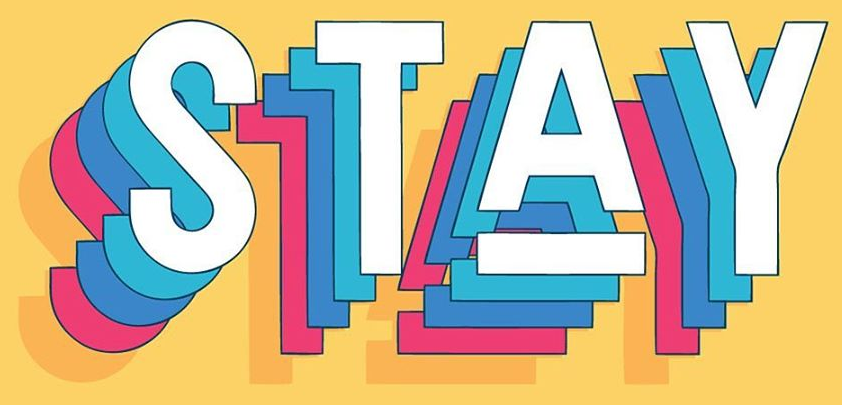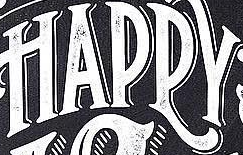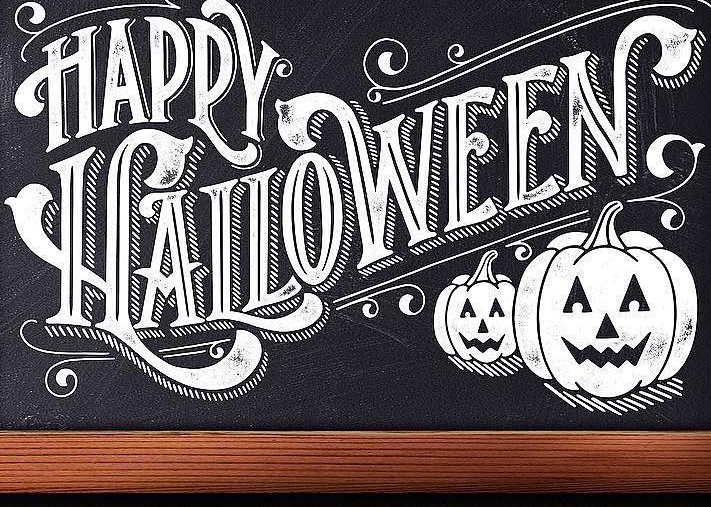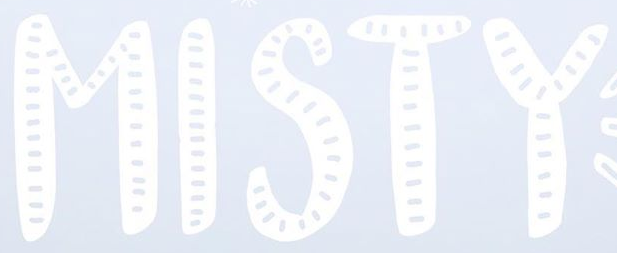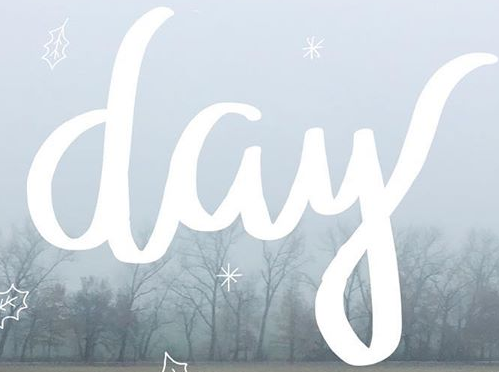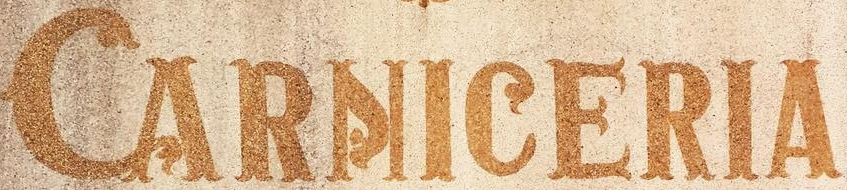Read the text from these images in sequence, separated by a semicolon. STAY; HAPPY; HALLOWEEN; MISTY; day; CARNICERIA 